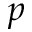<formula> <loc_0><loc_0><loc_500><loc_500>p</formula> 